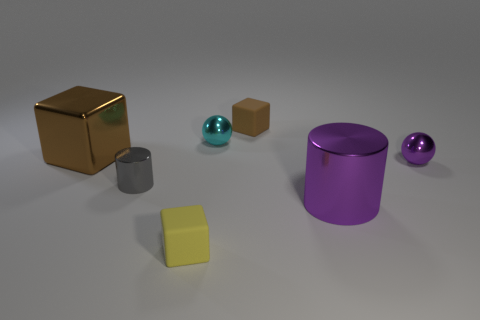There is a brown object that is the same material as the gray object; what shape is it?
Provide a succinct answer. Cube. The shiny object that is the same color as the big cylinder is what shape?
Your answer should be compact. Sphere. What is the shape of the small gray thing to the left of the large shiny object right of the gray shiny object?
Your response must be concise. Cylinder. There is a yellow rubber object that is the same size as the purple metallic sphere; what is its shape?
Offer a very short reply. Cube. Are there any small rubber cubes that have the same color as the tiny metallic cylinder?
Your answer should be compact. No. Is the number of small metallic things that are in front of the large brown metal block the same as the number of matte objects that are in front of the large purple metal thing?
Provide a succinct answer. No. Does the small cyan thing have the same shape as the purple thing that is behind the big cylinder?
Your response must be concise. Yes. How many other things are there of the same material as the tiny yellow object?
Offer a very short reply. 1. Are there any small metallic objects in front of the small cyan metallic ball?
Your response must be concise. Yes. There is a brown shiny object; is its size the same as the matte object to the right of the yellow thing?
Make the answer very short. No. 